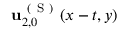Convert formula to latex. <formula><loc_0><loc_0><loc_500><loc_500>u _ { 2 , 0 } ^ { ( S ) } ( x - t , y )</formula> 